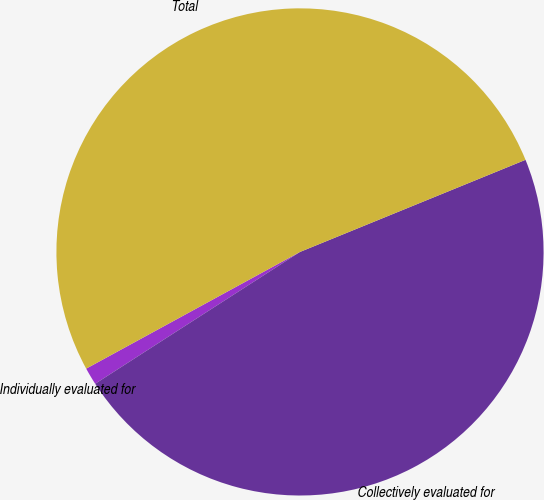Convert chart to OTSL. <chart><loc_0><loc_0><loc_500><loc_500><pie_chart><fcel>Individually evaluated for<fcel>Collectively evaluated for<fcel>Total<nl><fcel>1.15%<fcel>47.07%<fcel>51.78%<nl></chart> 